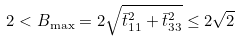Convert formula to latex. <formula><loc_0><loc_0><loc_500><loc_500>2 < B _ { \max } = 2 \sqrt { \bar { t } _ { 1 1 } ^ { 2 } + \bar { t } _ { 3 3 } ^ { 2 } } \leq 2 \sqrt { 2 }</formula> 